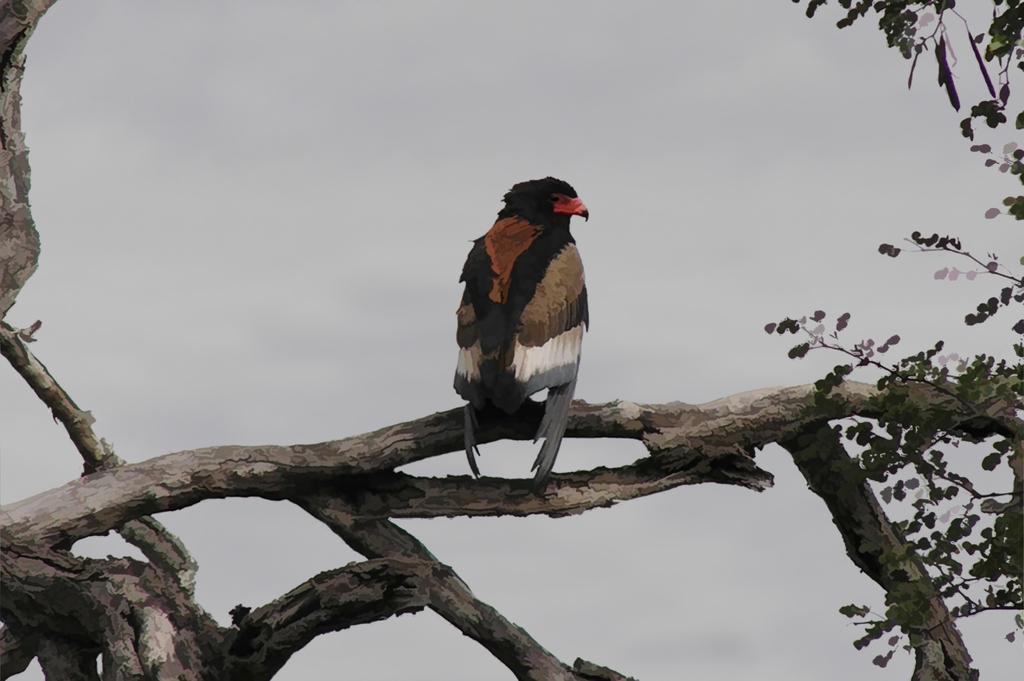Describe this image in one or two sentences. In this image we can see a bird on a branch of a tree. To the right side, we can see some leaves. In the background, we can see the sky. 